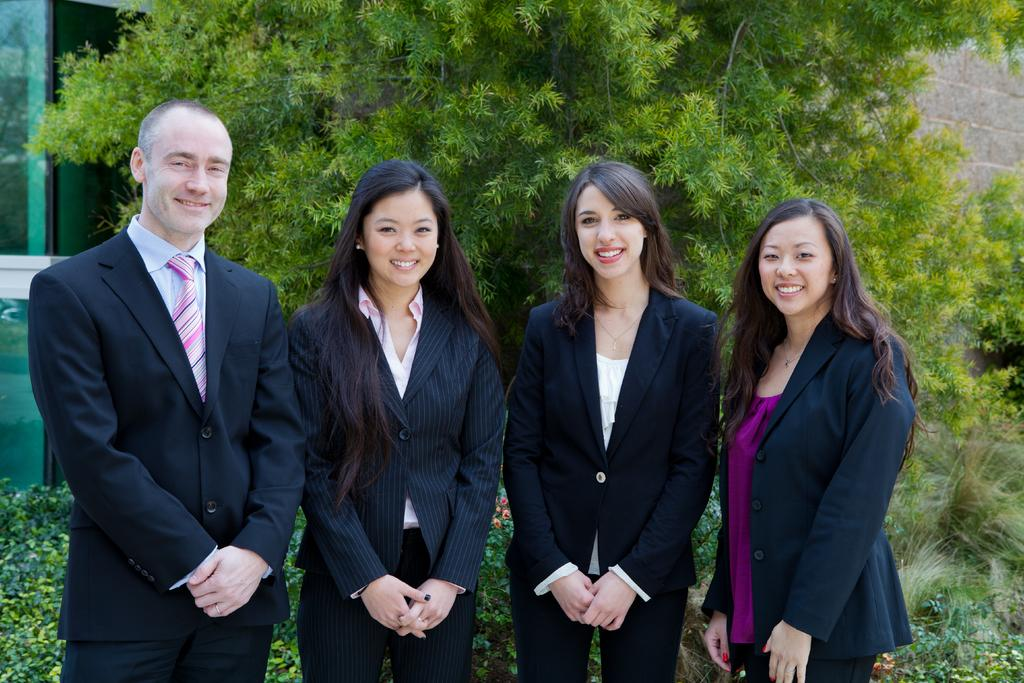How many people are present in the image? There are four persons in the image. What are the persons doing in the image? The persons are standing side by side, watching, and smiling. What can be seen in the background of the image? There are plants, trees, walls, and glass objects in the background of the image. What type of curve can be seen in the image? There is no curve present in the image. How many spiders are visible on the persons in the image? There are no spiders visible on the persons in the image. 